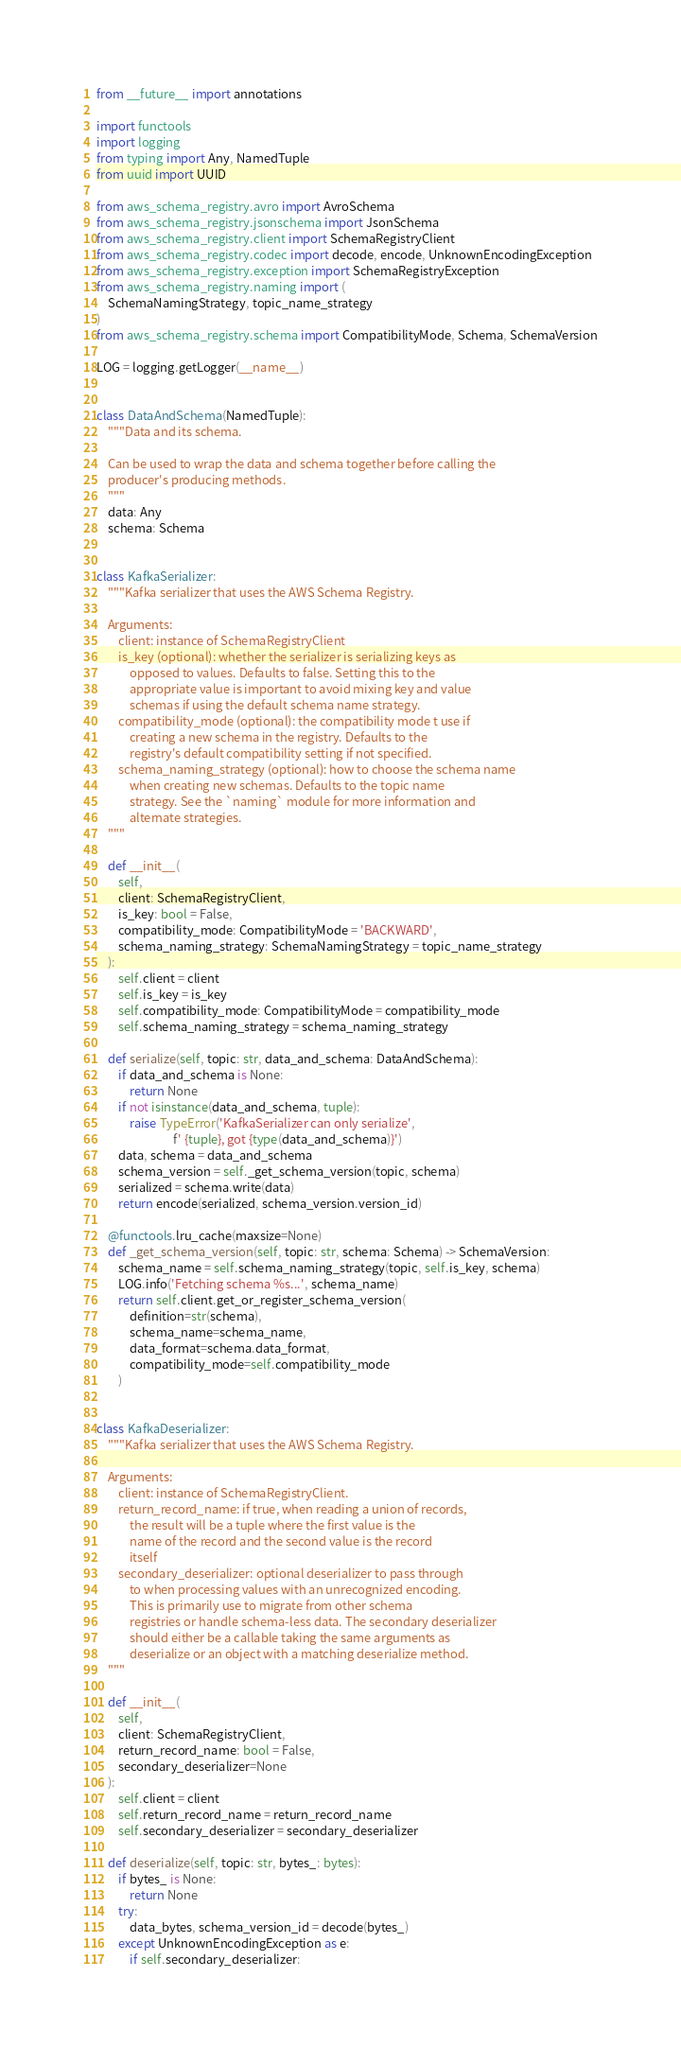Convert code to text. <code><loc_0><loc_0><loc_500><loc_500><_Python_>from __future__ import annotations

import functools
import logging
from typing import Any, NamedTuple
from uuid import UUID

from aws_schema_registry.avro import AvroSchema
from aws_schema_registry.jsonschema import JsonSchema
from aws_schema_registry.client import SchemaRegistryClient
from aws_schema_registry.codec import decode, encode, UnknownEncodingException
from aws_schema_registry.exception import SchemaRegistryException
from aws_schema_registry.naming import (
    SchemaNamingStrategy, topic_name_strategy
)
from aws_schema_registry.schema import CompatibilityMode, Schema, SchemaVersion

LOG = logging.getLogger(__name__)


class DataAndSchema(NamedTuple):
    """Data and its schema.

    Can be used to wrap the data and schema together before calling the
    producer's producing methods.
    """
    data: Any
    schema: Schema


class KafkaSerializer:
    """Kafka serializer that uses the AWS Schema Registry.

    Arguments:
        client: instance of SchemaRegistryClient
        is_key (optional): whether the serializer is serializing keys as
            opposed to values. Defaults to false. Setting this to the
            appropriate value is important to avoid mixing key and value
            schemas if using the default schema name strategy.
        compatibility_mode (optional): the compatibility mode t use if
            creating a new schema in the registry. Defaults to the
            registry's default compatibility setting if not specified.
        schema_naming_strategy (optional): how to choose the schema name
            when creating new schemas. Defaults to the topic name
            strategy. See the `naming` module for more information and
            alternate strategies.
    """

    def __init__(
        self,
        client: SchemaRegistryClient,
        is_key: bool = False,
        compatibility_mode: CompatibilityMode = 'BACKWARD',
        schema_naming_strategy: SchemaNamingStrategy = topic_name_strategy
    ):
        self.client = client
        self.is_key = is_key
        self.compatibility_mode: CompatibilityMode = compatibility_mode
        self.schema_naming_strategy = schema_naming_strategy

    def serialize(self, topic: str, data_and_schema: DataAndSchema):
        if data_and_schema is None:
            return None
        if not isinstance(data_and_schema, tuple):
            raise TypeError('KafkaSerializer can only serialize',
                            f' {tuple}, got {type(data_and_schema)}')
        data, schema = data_and_schema
        schema_version = self._get_schema_version(topic, schema)
        serialized = schema.write(data)
        return encode(serialized, schema_version.version_id)

    @functools.lru_cache(maxsize=None)
    def _get_schema_version(self, topic: str, schema: Schema) -> SchemaVersion:
        schema_name = self.schema_naming_strategy(topic, self.is_key, schema)
        LOG.info('Fetching schema %s...', schema_name)
        return self.client.get_or_register_schema_version(
            definition=str(schema),
            schema_name=schema_name,
            data_format=schema.data_format,
            compatibility_mode=self.compatibility_mode
        )


class KafkaDeserializer:
    """Kafka serializer that uses the AWS Schema Registry.

    Arguments:
        client: instance of SchemaRegistryClient.
        return_record_name: if true, when reading a union of records,
            the result will be a tuple where the first value is the
            name of the record and the second value is the record
            itself
        secondary_deserializer: optional deserializer to pass through
            to when processing values with an unrecognized encoding.
            This is primarily use to migrate from other schema
            registries or handle schema-less data. The secondary deserializer
            should either be a callable taking the same arguments as
            deserialize or an object with a matching deserialize method.
    """

    def __init__(
        self,
        client: SchemaRegistryClient,
        return_record_name: bool = False,
        secondary_deserializer=None
    ):
        self.client = client
        self.return_record_name = return_record_name
        self.secondary_deserializer = secondary_deserializer

    def deserialize(self, topic: str, bytes_: bytes):
        if bytes_ is None:
            return None
        try:
            data_bytes, schema_version_id = decode(bytes_)
        except UnknownEncodingException as e:
            if self.secondary_deserializer:</code> 